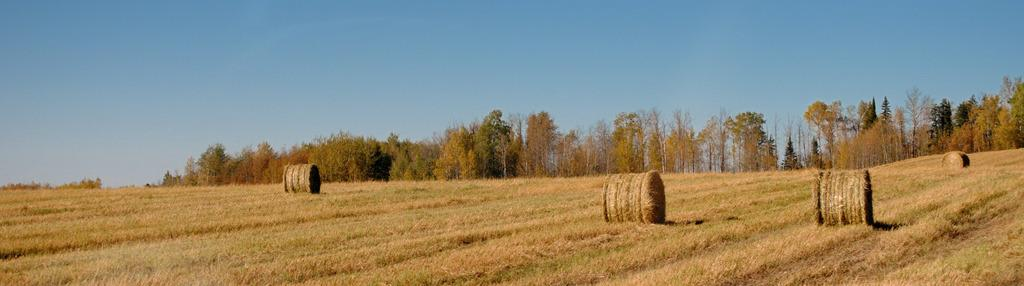What type of landscape is depicted in the picture? The picture shows farmlands. Are there any other natural elements in the picture besides farmlands? Yes, there are trees in the picture. What is visible at the top of the picture? The sky is clear and visible at the top of the picture. How many balls can be seen rolling through the farmlands in the picture? There are no balls present in the picture; it features farmlands and trees. What type of metal is used to construct the farm in the picture? The picture does not show any construction materials or structures; it only depicts farmlands and trees. 